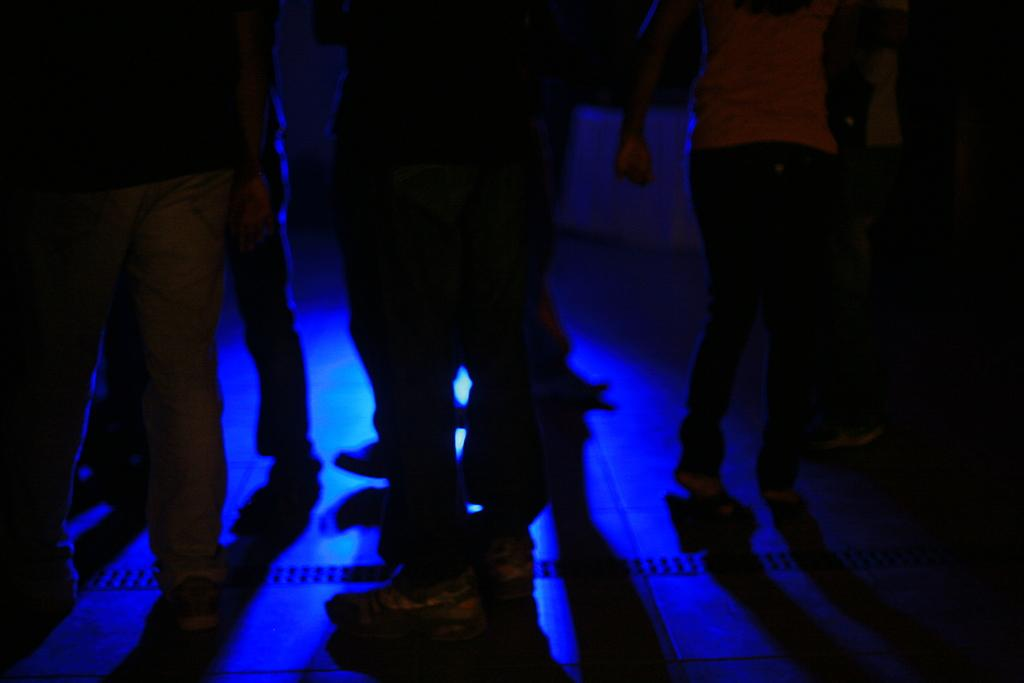What can be seen in the image? There are people standing in the image. Where are the people standing? The people are standing on the floor. What type of clothing are the people wearing on their lower bodies? The people are wearing pants. What type of clothing are the people wearing on their upper bodies? The people are wearing shirts. What type of bean is being served to the people in the image? There is no bean present in the image, and no indication that the people are being served any food. 